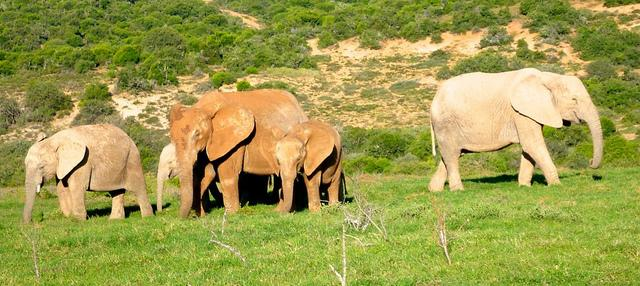What color is the elephant on the right? grey 